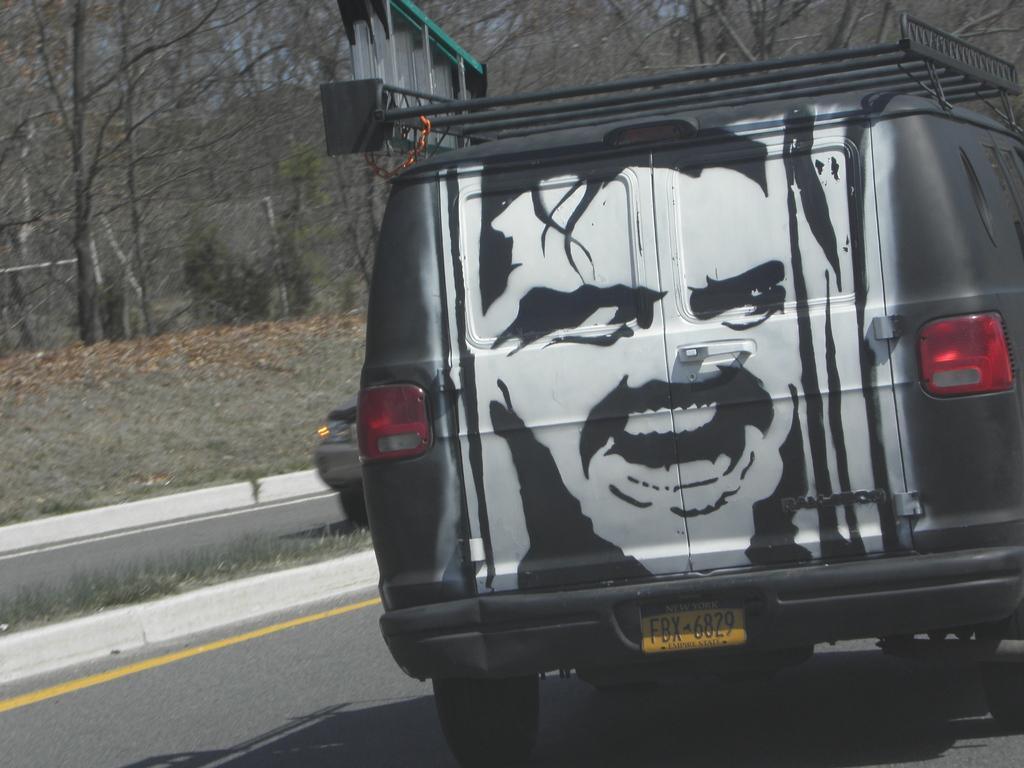Please provide a concise description of this image. In the center of the image there is a vehicle on the road. In the background there are trees, plants, road and car. 